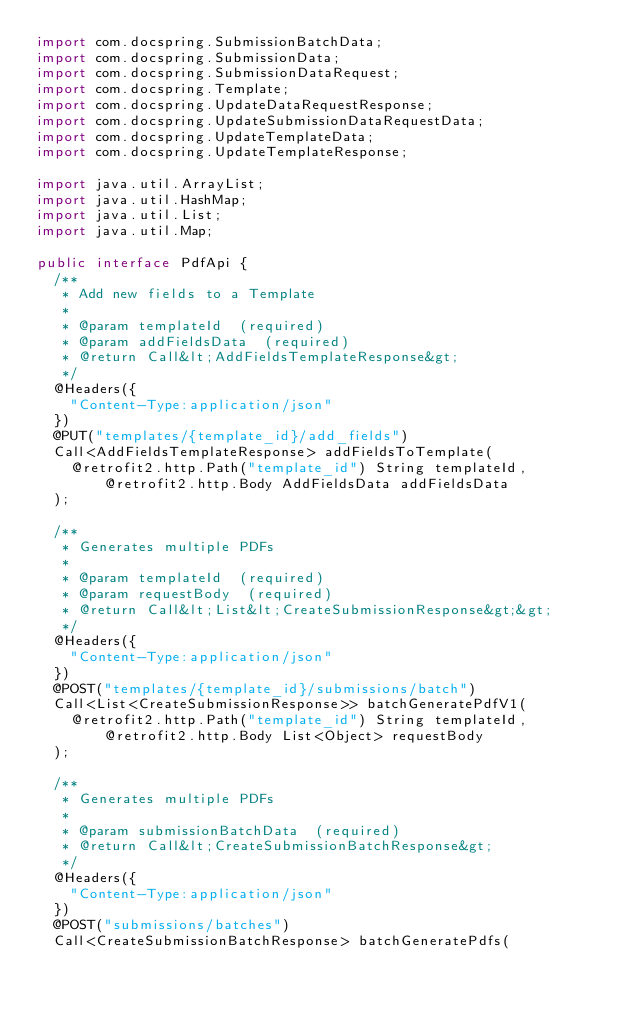Convert code to text. <code><loc_0><loc_0><loc_500><loc_500><_Java_>import com.docspring.SubmissionBatchData;
import com.docspring.SubmissionData;
import com.docspring.SubmissionDataRequest;
import com.docspring.Template;
import com.docspring.UpdateDataRequestResponse;
import com.docspring.UpdateSubmissionDataRequestData;
import com.docspring.UpdateTemplateData;
import com.docspring.UpdateTemplateResponse;

import java.util.ArrayList;
import java.util.HashMap;
import java.util.List;
import java.util.Map;

public interface PdfApi {
  /**
   * Add new fields to a Template
   * 
   * @param templateId  (required)
   * @param addFieldsData  (required)
   * @return Call&lt;AddFieldsTemplateResponse&gt;
   */
  @Headers({
    "Content-Type:application/json"
  })
  @PUT("templates/{template_id}/add_fields")
  Call<AddFieldsTemplateResponse> addFieldsToTemplate(
    @retrofit2.http.Path("template_id") String templateId, @retrofit2.http.Body AddFieldsData addFieldsData
  );

  /**
   * Generates multiple PDFs
   * 
   * @param templateId  (required)
   * @param requestBody  (required)
   * @return Call&lt;List&lt;CreateSubmissionResponse&gt;&gt;
   */
  @Headers({
    "Content-Type:application/json"
  })
  @POST("templates/{template_id}/submissions/batch")
  Call<List<CreateSubmissionResponse>> batchGeneratePdfV1(
    @retrofit2.http.Path("template_id") String templateId, @retrofit2.http.Body List<Object> requestBody
  );

  /**
   * Generates multiple PDFs
   * 
   * @param submissionBatchData  (required)
   * @return Call&lt;CreateSubmissionBatchResponse&gt;
   */
  @Headers({
    "Content-Type:application/json"
  })
  @POST("submissions/batches")
  Call<CreateSubmissionBatchResponse> batchGeneratePdfs(</code> 